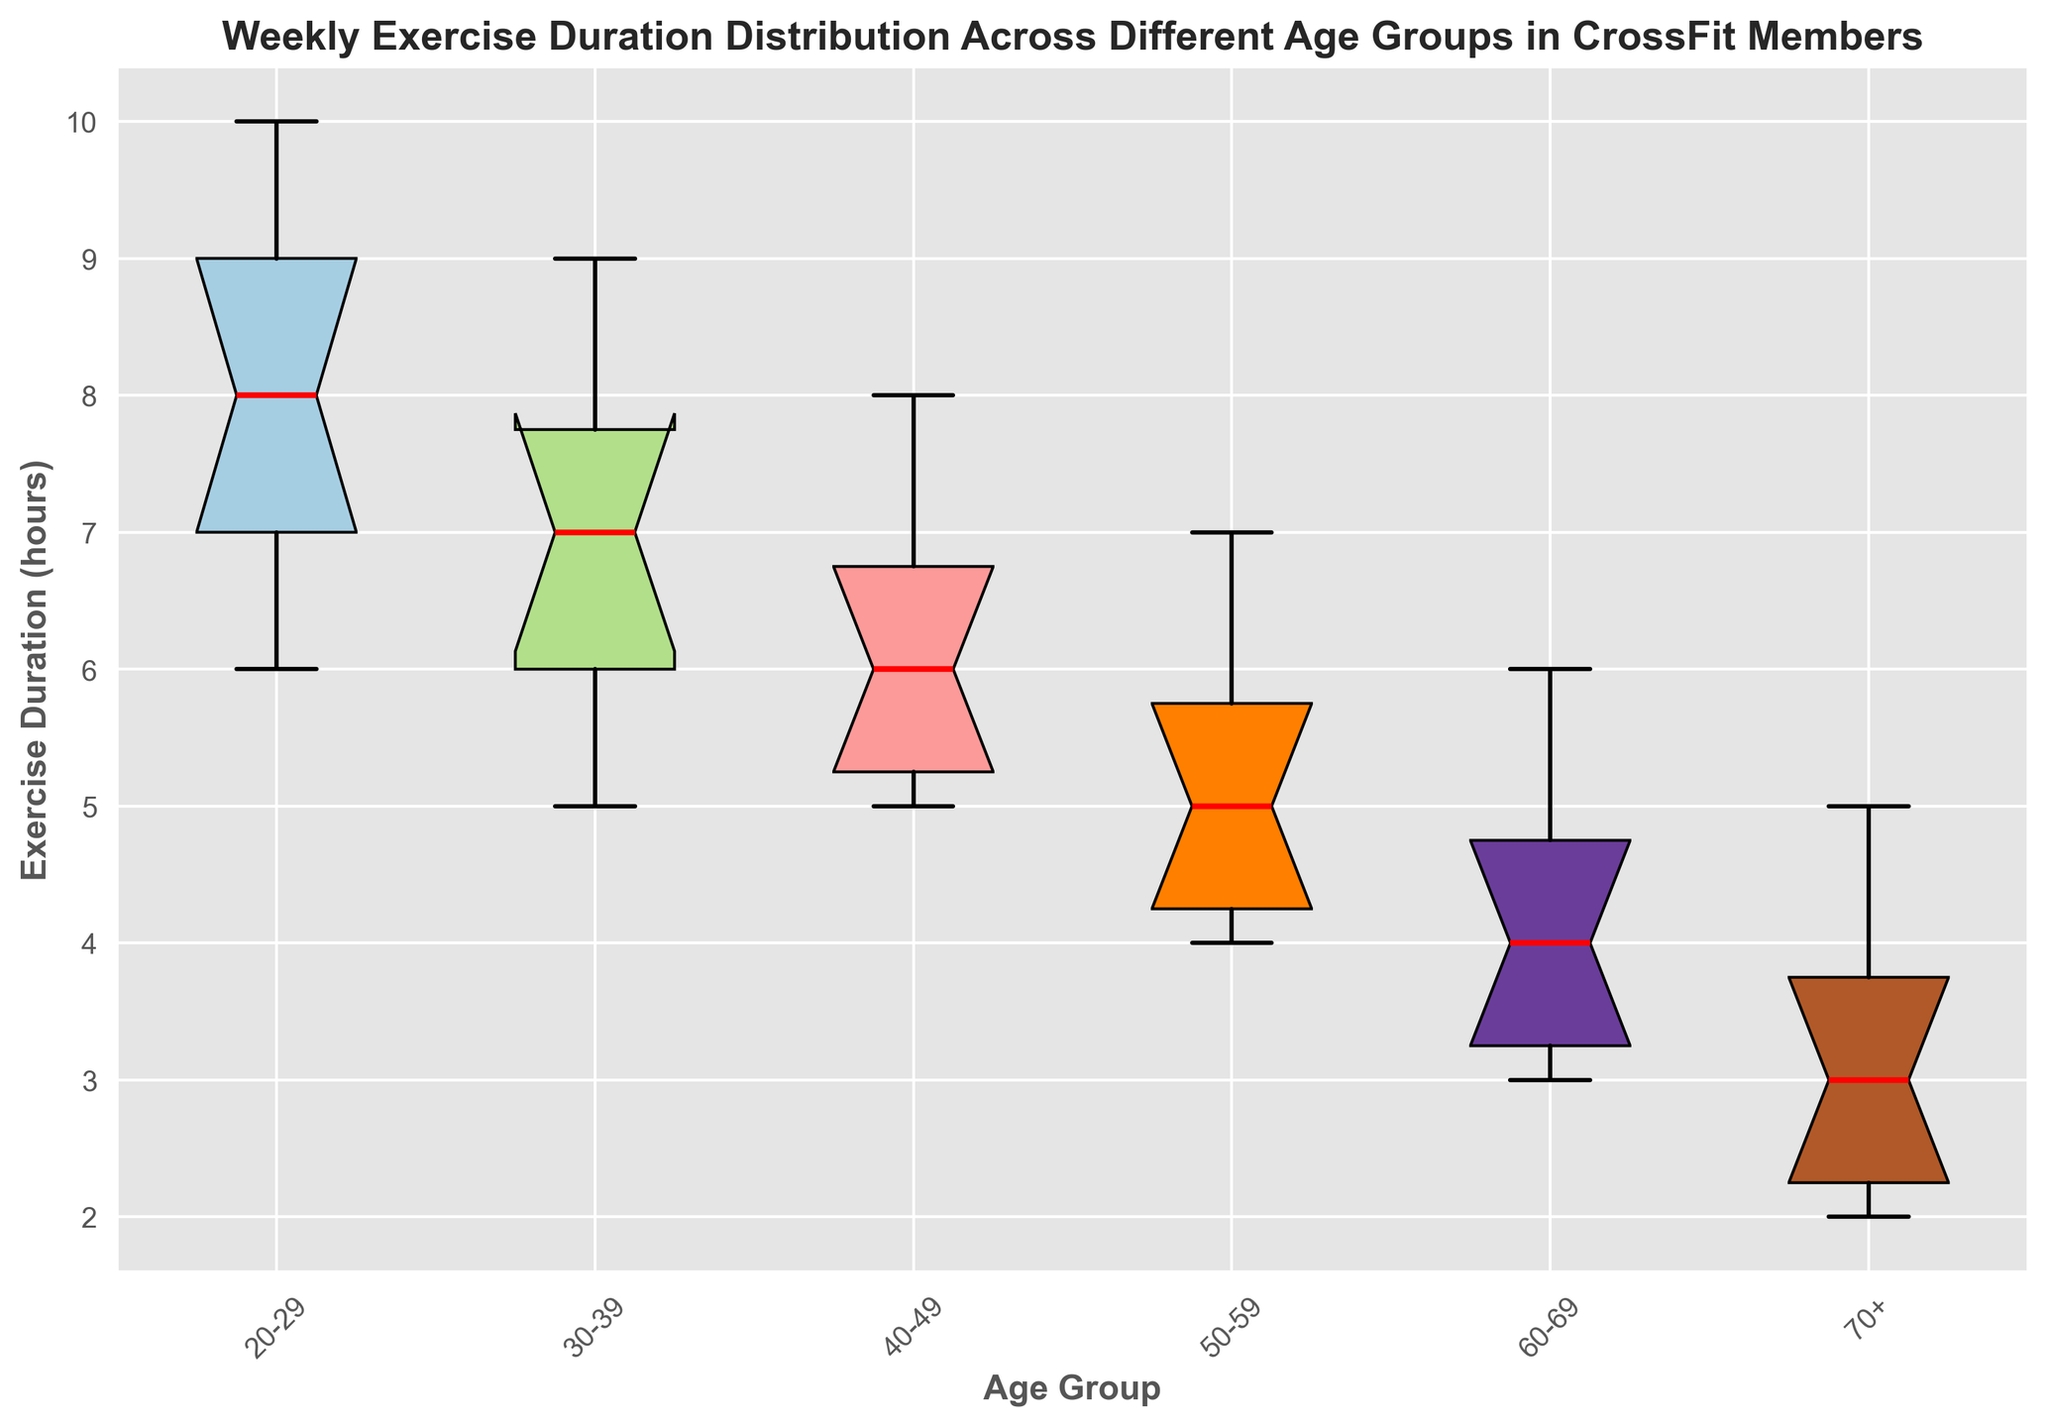What is the range of exercise durations for the age group 20-29? To find the range, look at the minimum and maximum values of the box plot for this age group. The minimum value is represented by the lower whisker and the maximum value by the upper whisker.
Answer: 4 hours Which age group has the highest median exercise duration? The median value is indicated by the red line inside each box. Compare the red lines across all groups to identify which one is the highest.
Answer: 20-29 Is the interquartile range (IQR) wider for the age group 40-49 or 50-59? The IQR is the distance between the first (lower) and third (upper) quartile boundaries of the box. Compare the width of the boxes for these two age groups.
Answer: 40-49 Which age group has the most consistent exercise duration? Consistency refers to the smallest variability, which can be inferred by the smallest IQR. Look for the narrowest box in the plot.
Answer: 70+ What is the median exercise duration for the age group 60-69? The median value is represented by the red line inside the box for the 60-69 age group.
Answer: 4 hours Which two age groups have the most similar median exercise duration? Compare the red median lines across all age groups to find the two that are closest to each other.
Answer: 40-49 and 50-59 Which age group has the largest variance in exercise duration? The variance can be roughly estimated by looking at the overall length of the box plot (including whiskers). Find the group with the longest box plot.
Answer: 20-29 How does the median exercise duration of the 60-69 age group compare to the 30-39 age group? Compare the height of the red lines representing the median in both age groups to see which is higher or lower.
Answer: Lower What is the difference in the upper quartile (third quartile) between the age groups 20-29 and 70+? Locate the top edge of the boxes for both age groups to find the respective third quartiles, then subtract the value for 70+ from 20-29.
Answer: 6 hours Which age group has the lowest exercise duration outlier, and what is the value? Outliers are typically represented by points outside the whiskers. Identify the lowest point for each group and compare.
Answer: 70+, 2 hours 